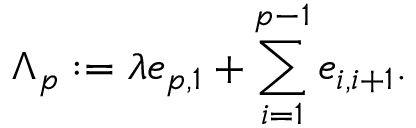Convert formula to latex. <formula><loc_0><loc_0><loc_500><loc_500>\Lambda _ { p } \colon = \lambda e _ { p , 1 } + \sum _ { i = 1 } ^ { p - 1 } e _ { i , i + 1 } .</formula> 